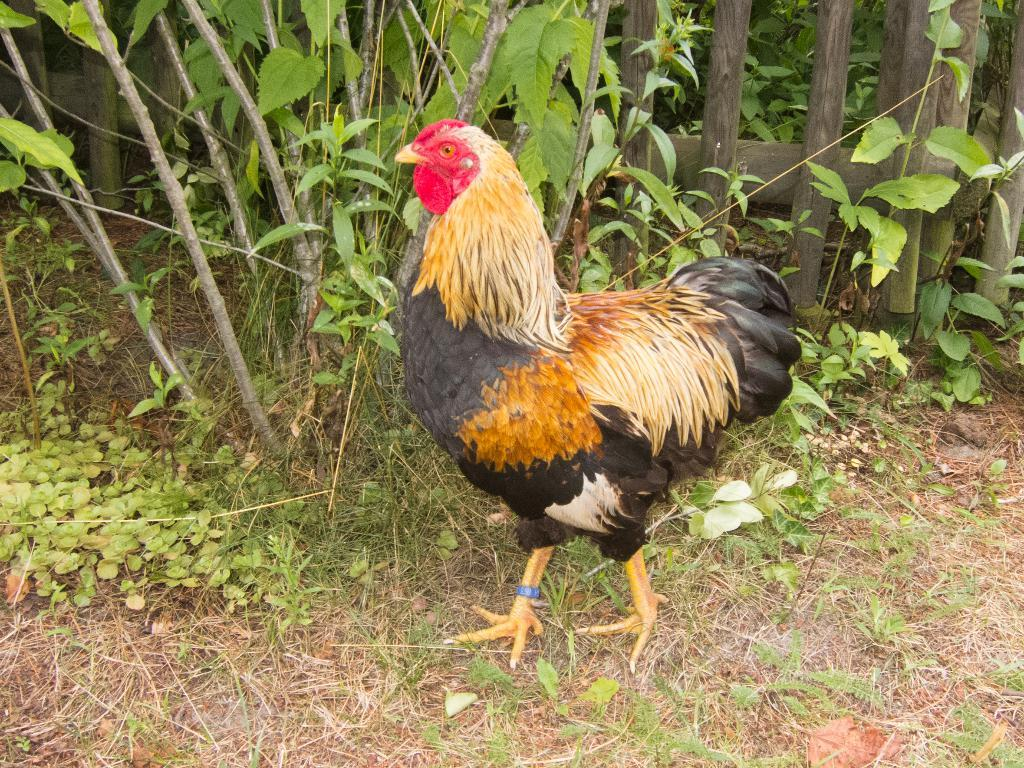What type of animal is in the image? There is a hen in the image. Where is the hen located? The hen is on the grass. What can be seen in the background of the image? There are plants visible in the image. What type of fencing is present in the image? There is wooden fencing in the image. What type of society is depicted in the image? There is no society depicted in the image; it features a hen on the grass with plants and wooden fencing in the background. 